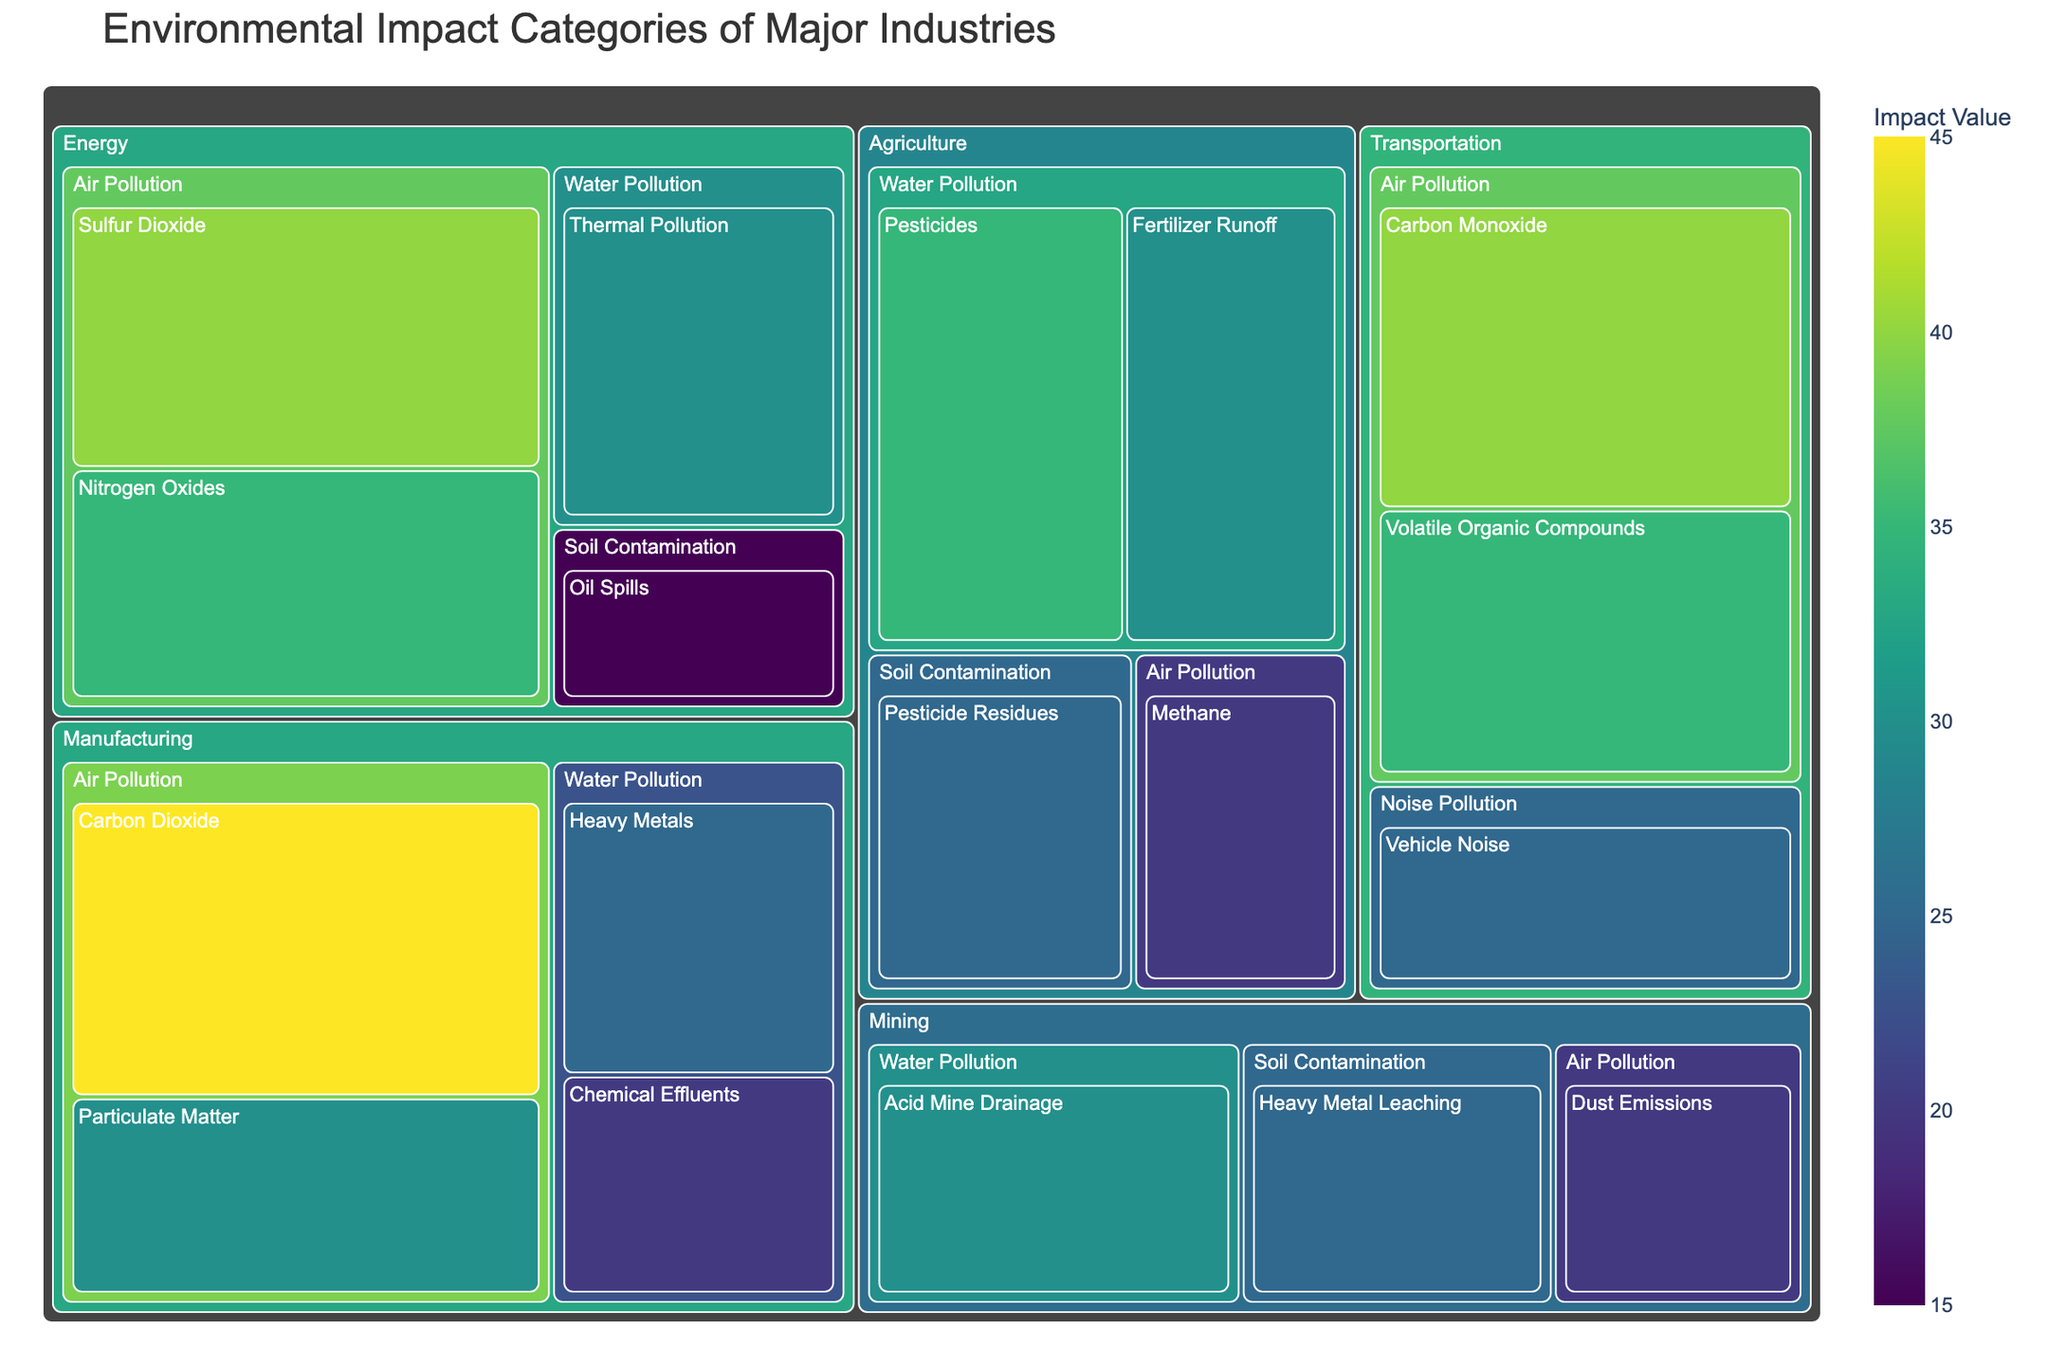What is the title of the treemap? The title of the treemap is generally displayed at the top of the figure. By reading the top part of the figure, we can identify the title.
Answer: Environmental Impact Categories of Major Industries Which industry has the highest air pollution value? To determine which industry has the highest air pollution value, we examine the individual values of the air pollution types within each industry and compare their sums.
Answer: Manufacturing What is the combined value of water pollution in Agriculture? To find the combined value of water pollution in Agriculture, we sum specific pollution values within the Agriculture industry: Pesticides, and Fertilizer Runoff. 35 + 30 = 65
Answer: 65 How does the air pollution from Transportation compare to that from Energy? We need to sum up the air pollution values for both industries. For Transportation: Carbon Monoxide (40) + Volatile Organic Compounds (35) = 75. For Energy: Sulfur Dioxide (40) + Nitrogen Oxides (35) = 75. They are equal.
Answer: Equal Which pollution type has the smallest impact in the Energy industry? Within the Energy industry, compare the given values for each pollution type. The smallest value is for Soil Contamination: Oil Spills (15).
Answer: Oil Spills What is the average value of the water pollution categories across all industries? Identify all the values related to water pollution from the treemap, then calculate the average: (25 + 20 + 30 + 35 + 30) / 5 = 28.
Answer: 28 How many different pollution types are listed in the Agriculture industry? In the Agriculture industry, count the unique pollution types specified in the treemap. There are four: Pesticides, Fertilizer Runoff, Pesticide Residues, and Methane.
Answer: 4 What's the total environmental impact value for the Manufacturing industry? Sum the values of all pollution types within the Manufacturing industry: Carbon Dioxide (45) + Particulate Matter (30) + Heavy Metals (25) + Chemical Effluents (20) = 120.
Answer: 120 Between Waste Water Pollution and Air Pollution in Manufacturing, which category has a higher combined value? Sum the values for each category: Air Pollution (Carbon Dioxide 45 + Particulate Matter 30 = 75) and Water Pollution (Heavy Metals 25 + Chemical Effluents 20 = 45). Air Pollution is higher.
Answer: Air Pollution 